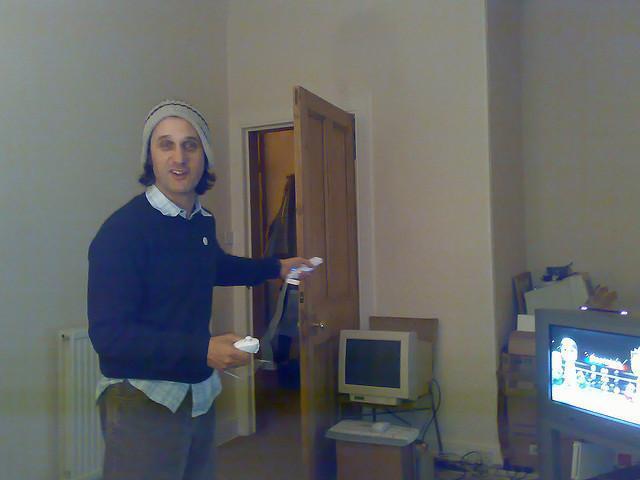How many people are there?
Give a very brief answer. 1. How many tvs can be seen?
Give a very brief answer. 2. 